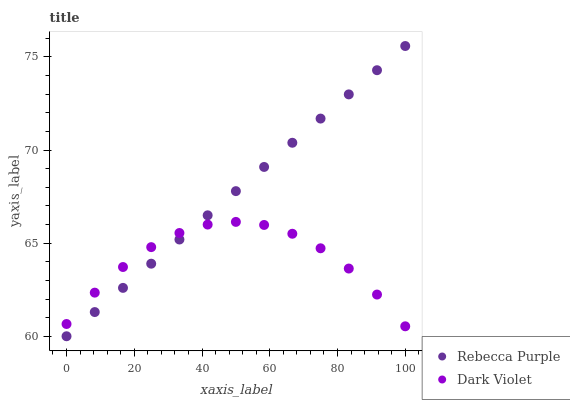Does Dark Violet have the minimum area under the curve?
Answer yes or no. Yes. Does Rebecca Purple have the maximum area under the curve?
Answer yes or no. Yes. Does Dark Violet have the maximum area under the curve?
Answer yes or no. No. Is Rebecca Purple the smoothest?
Answer yes or no. Yes. Is Dark Violet the roughest?
Answer yes or no. Yes. Is Dark Violet the smoothest?
Answer yes or no. No. Does Rebecca Purple have the lowest value?
Answer yes or no. Yes. Does Dark Violet have the lowest value?
Answer yes or no. No. Does Rebecca Purple have the highest value?
Answer yes or no. Yes. Does Dark Violet have the highest value?
Answer yes or no. No. Does Dark Violet intersect Rebecca Purple?
Answer yes or no. Yes. Is Dark Violet less than Rebecca Purple?
Answer yes or no. No. Is Dark Violet greater than Rebecca Purple?
Answer yes or no. No. 